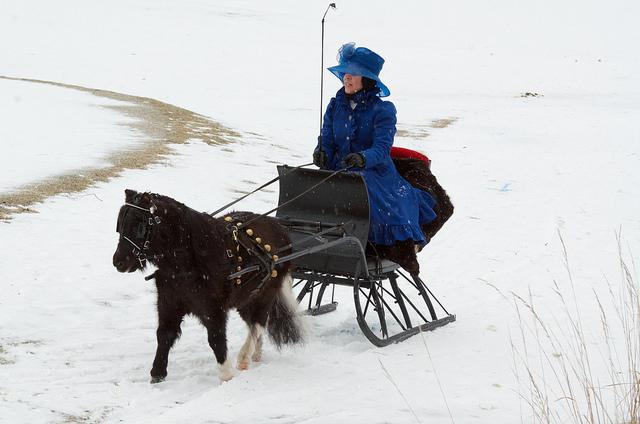Is this a large horse?
Concise answer only. No. Is the horse running?
Give a very brief answer. No. How many people are riding on this sled?
Answer briefly. 1. 